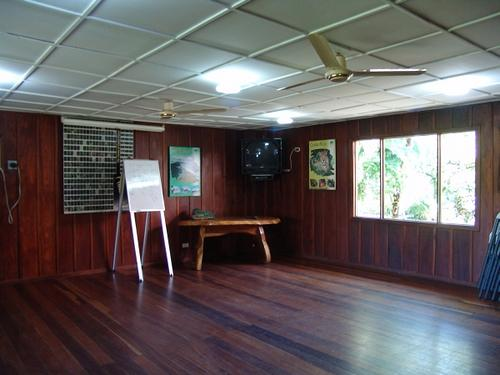What item here would an artist use?

Choices:
A) purple marker
B) easel
C) cat carrier
D) smock easel 